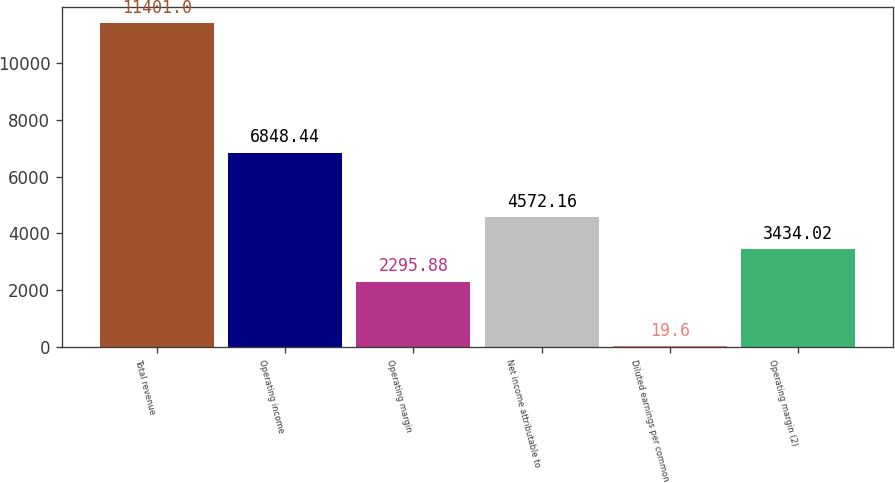<chart> <loc_0><loc_0><loc_500><loc_500><bar_chart><fcel>Total revenue<fcel>Operating income<fcel>Operating margin<fcel>Net income attributable to<fcel>Diluted earnings per common<fcel>Operating margin (2)<nl><fcel>11401<fcel>6848.44<fcel>2295.88<fcel>4572.16<fcel>19.6<fcel>3434.02<nl></chart> 